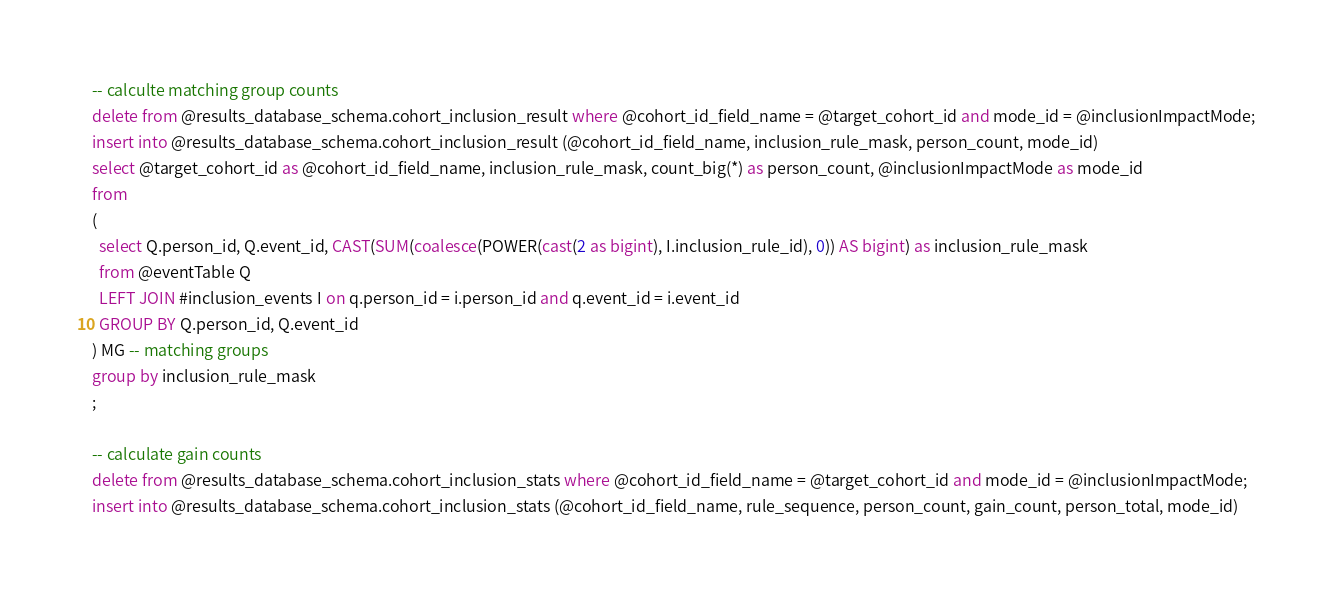Convert code to text. <code><loc_0><loc_0><loc_500><loc_500><_SQL_>-- calculte matching group counts
delete from @results_database_schema.cohort_inclusion_result where @cohort_id_field_name = @target_cohort_id and mode_id = @inclusionImpactMode;
insert into @results_database_schema.cohort_inclusion_result (@cohort_id_field_name, inclusion_rule_mask, person_count, mode_id)
select @target_cohort_id as @cohort_id_field_name, inclusion_rule_mask, count_big(*) as person_count, @inclusionImpactMode as mode_id
from
(
  select Q.person_id, Q.event_id, CAST(SUM(coalesce(POWER(cast(2 as bigint), I.inclusion_rule_id), 0)) AS bigint) as inclusion_rule_mask
  from @eventTable Q
  LEFT JOIN #inclusion_events I on q.person_id = i.person_id and q.event_id = i.event_id
  GROUP BY Q.person_id, Q.event_id
) MG -- matching groups
group by inclusion_rule_mask
;

-- calculate gain counts 
delete from @results_database_schema.cohort_inclusion_stats where @cohort_id_field_name = @target_cohort_id and mode_id = @inclusionImpactMode;
insert into @results_database_schema.cohort_inclusion_stats (@cohort_id_field_name, rule_sequence, person_count, gain_count, person_total, mode_id)</code> 